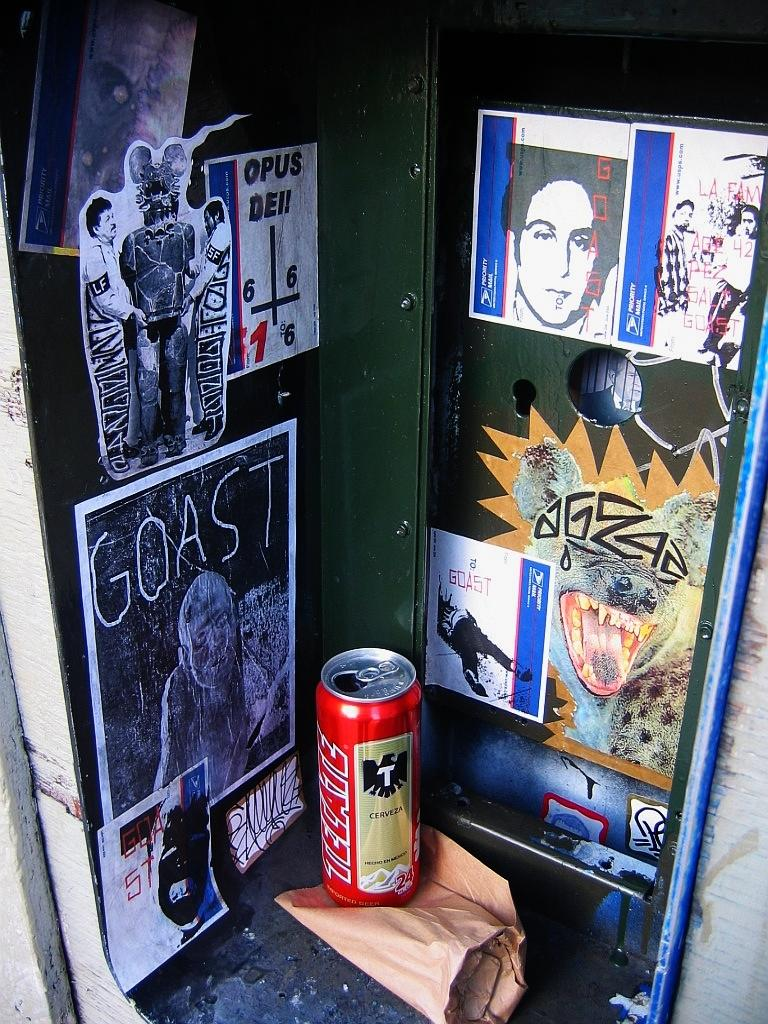<image>
Share a concise interpretation of the image provided. An open can of Tecate beer sits by various stickers and posters. 